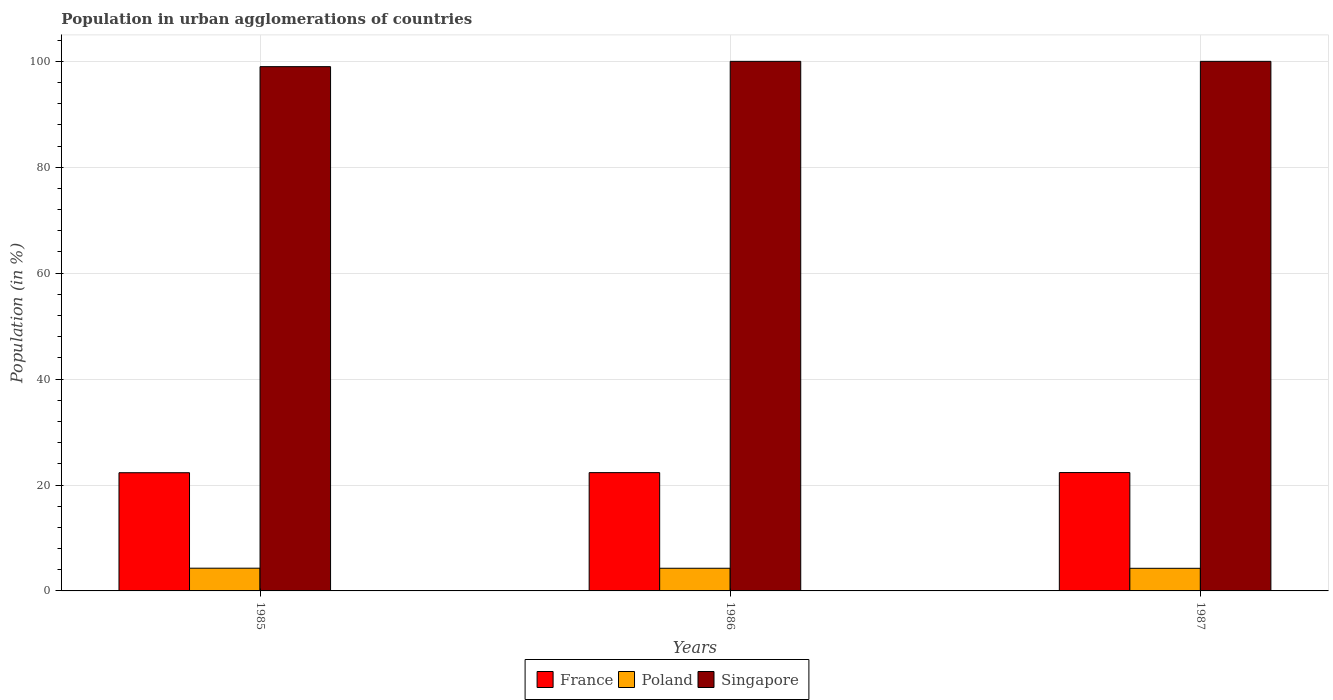How many different coloured bars are there?
Your answer should be compact. 3. Are the number of bars on each tick of the X-axis equal?
Provide a succinct answer. Yes. What is the label of the 1st group of bars from the left?
Provide a succinct answer. 1985. In how many cases, is the number of bars for a given year not equal to the number of legend labels?
Give a very brief answer. 0. What is the percentage of population in urban agglomerations in Poland in 1986?
Provide a succinct answer. 4.28. Across all years, what is the minimum percentage of population in urban agglomerations in Singapore?
Your answer should be very brief. 99. In which year was the percentage of population in urban agglomerations in Poland maximum?
Give a very brief answer. 1985. What is the total percentage of population in urban agglomerations in France in the graph?
Your response must be concise. 67. What is the difference between the percentage of population in urban agglomerations in Poland in 1985 and that in 1987?
Your answer should be compact. 0.02. What is the difference between the percentage of population in urban agglomerations in France in 1987 and the percentage of population in urban agglomerations in Poland in 1985?
Your answer should be compact. 18.06. What is the average percentage of population in urban agglomerations in France per year?
Your response must be concise. 22.33. In the year 1985, what is the difference between the percentage of population in urban agglomerations in Singapore and percentage of population in urban agglomerations in France?
Keep it short and to the point. 76.68. In how many years, is the percentage of population in urban agglomerations in France greater than 72 %?
Your answer should be very brief. 0. What is the ratio of the percentage of population in urban agglomerations in Singapore in 1985 to that in 1987?
Provide a succinct answer. 0.99. Is the percentage of population in urban agglomerations in Poland in 1985 less than that in 1986?
Provide a succinct answer. No. Is the difference between the percentage of population in urban agglomerations in Singapore in 1986 and 1987 greater than the difference between the percentage of population in urban agglomerations in France in 1986 and 1987?
Give a very brief answer. Yes. What is the difference between the highest and the lowest percentage of population in urban agglomerations in Singapore?
Your answer should be very brief. 1. In how many years, is the percentage of population in urban agglomerations in Poland greater than the average percentage of population in urban agglomerations in Poland taken over all years?
Provide a short and direct response. 1. What does the 2nd bar from the left in 1987 represents?
Ensure brevity in your answer.  Poland. What does the 2nd bar from the right in 1986 represents?
Provide a short and direct response. Poland. How many bars are there?
Give a very brief answer. 9. Are the values on the major ticks of Y-axis written in scientific E-notation?
Provide a short and direct response. No. Does the graph contain any zero values?
Give a very brief answer. No. Where does the legend appear in the graph?
Your answer should be very brief. Bottom center. How many legend labels are there?
Your answer should be compact. 3. What is the title of the graph?
Make the answer very short. Population in urban agglomerations of countries. Does "Arab World" appear as one of the legend labels in the graph?
Your response must be concise. No. What is the Population (in %) of France in 1985?
Provide a short and direct response. 22.32. What is the Population (in %) of Poland in 1985?
Offer a very short reply. 4.29. What is the Population (in %) of Singapore in 1985?
Your answer should be compact. 99. What is the Population (in %) in France in 1986?
Ensure brevity in your answer.  22.34. What is the Population (in %) of Poland in 1986?
Offer a terse response. 4.28. What is the Population (in %) of France in 1987?
Provide a succinct answer. 22.35. What is the Population (in %) in Poland in 1987?
Provide a short and direct response. 4.27. What is the Population (in %) in Singapore in 1987?
Your response must be concise. 100. Across all years, what is the maximum Population (in %) in France?
Your response must be concise. 22.35. Across all years, what is the maximum Population (in %) of Poland?
Offer a terse response. 4.29. Across all years, what is the minimum Population (in %) of France?
Make the answer very short. 22.32. Across all years, what is the minimum Population (in %) in Poland?
Make the answer very short. 4.27. Across all years, what is the minimum Population (in %) of Singapore?
Your response must be concise. 99. What is the total Population (in %) of France in the graph?
Keep it short and to the point. 67. What is the total Population (in %) in Poland in the graph?
Make the answer very short. 12.84. What is the total Population (in %) of Singapore in the graph?
Provide a short and direct response. 299. What is the difference between the Population (in %) in France in 1985 and that in 1986?
Your answer should be compact. -0.02. What is the difference between the Population (in %) in Poland in 1985 and that in 1986?
Your answer should be compact. 0.01. What is the difference between the Population (in %) of Singapore in 1985 and that in 1986?
Offer a terse response. -1. What is the difference between the Population (in %) in France in 1985 and that in 1987?
Offer a very short reply. -0.03. What is the difference between the Population (in %) in Poland in 1985 and that in 1987?
Keep it short and to the point. 0.02. What is the difference between the Population (in %) in Singapore in 1985 and that in 1987?
Offer a very short reply. -1. What is the difference between the Population (in %) of France in 1986 and that in 1987?
Keep it short and to the point. -0.01. What is the difference between the Population (in %) in Poland in 1986 and that in 1987?
Offer a terse response. 0.01. What is the difference between the Population (in %) in Singapore in 1986 and that in 1987?
Provide a short and direct response. 0. What is the difference between the Population (in %) in France in 1985 and the Population (in %) in Poland in 1986?
Keep it short and to the point. 18.04. What is the difference between the Population (in %) in France in 1985 and the Population (in %) in Singapore in 1986?
Your answer should be compact. -77.68. What is the difference between the Population (in %) of Poland in 1985 and the Population (in %) of Singapore in 1986?
Make the answer very short. -95.71. What is the difference between the Population (in %) of France in 1985 and the Population (in %) of Poland in 1987?
Your response must be concise. 18.05. What is the difference between the Population (in %) in France in 1985 and the Population (in %) in Singapore in 1987?
Provide a short and direct response. -77.68. What is the difference between the Population (in %) of Poland in 1985 and the Population (in %) of Singapore in 1987?
Offer a very short reply. -95.71. What is the difference between the Population (in %) in France in 1986 and the Population (in %) in Poland in 1987?
Your answer should be very brief. 18.06. What is the difference between the Population (in %) in France in 1986 and the Population (in %) in Singapore in 1987?
Provide a succinct answer. -77.66. What is the difference between the Population (in %) of Poland in 1986 and the Population (in %) of Singapore in 1987?
Keep it short and to the point. -95.72. What is the average Population (in %) in France per year?
Your answer should be very brief. 22.33. What is the average Population (in %) of Poland per year?
Provide a short and direct response. 4.28. What is the average Population (in %) in Singapore per year?
Make the answer very short. 99.67. In the year 1985, what is the difference between the Population (in %) of France and Population (in %) of Poland?
Ensure brevity in your answer.  18.03. In the year 1985, what is the difference between the Population (in %) of France and Population (in %) of Singapore?
Provide a short and direct response. -76.68. In the year 1985, what is the difference between the Population (in %) in Poland and Population (in %) in Singapore?
Give a very brief answer. -94.71. In the year 1986, what is the difference between the Population (in %) of France and Population (in %) of Poland?
Give a very brief answer. 18.06. In the year 1986, what is the difference between the Population (in %) in France and Population (in %) in Singapore?
Keep it short and to the point. -77.66. In the year 1986, what is the difference between the Population (in %) of Poland and Population (in %) of Singapore?
Offer a terse response. -95.72. In the year 1987, what is the difference between the Population (in %) of France and Population (in %) of Poland?
Provide a succinct answer. 18.08. In the year 1987, what is the difference between the Population (in %) in France and Population (in %) in Singapore?
Offer a terse response. -77.65. In the year 1987, what is the difference between the Population (in %) in Poland and Population (in %) in Singapore?
Provide a short and direct response. -95.73. What is the ratio of the Population (in %) of France in 1985 to that in 1987?
Keep it short and to the point. 1. What is the ratio of the Population (in %) of Poland in 1985 to that in 1987?
Provide a succinct answer. 1. What is the ratio of the Population (in %) of Singapore in 1985 to that in 1987?
Your response must be concise. 0.99. What is the ratio of the Population (in %) in Singapore in 1986 to that in 1987?
Provide a short and direct response. 1. What is the difference between the highest and the second highest Population (in %) of France?
Your answer should be very brief. 0.01. What is the difference between the highest and the second highest Population (in %) of Poland?
Make the answer very short. 0.01. What is the difference between the highest and the lowest Population (in %) in France?
Give a very brief answer. 0.03. What is the difference between the highest and the lowest Population (in %) in Poland?
Provide a succinct answer. 0.02. What is the difference between the highest and the lowest Population (in %) of Singapore?
Offer a terse response. 1. 